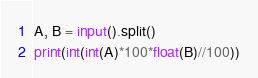Convert code to text. <code><loc_0><loc_0><loc_500><loc_500><_Python_>A, B = input().split()
print(int(int(A)*100*float(B)//100))
</code> 